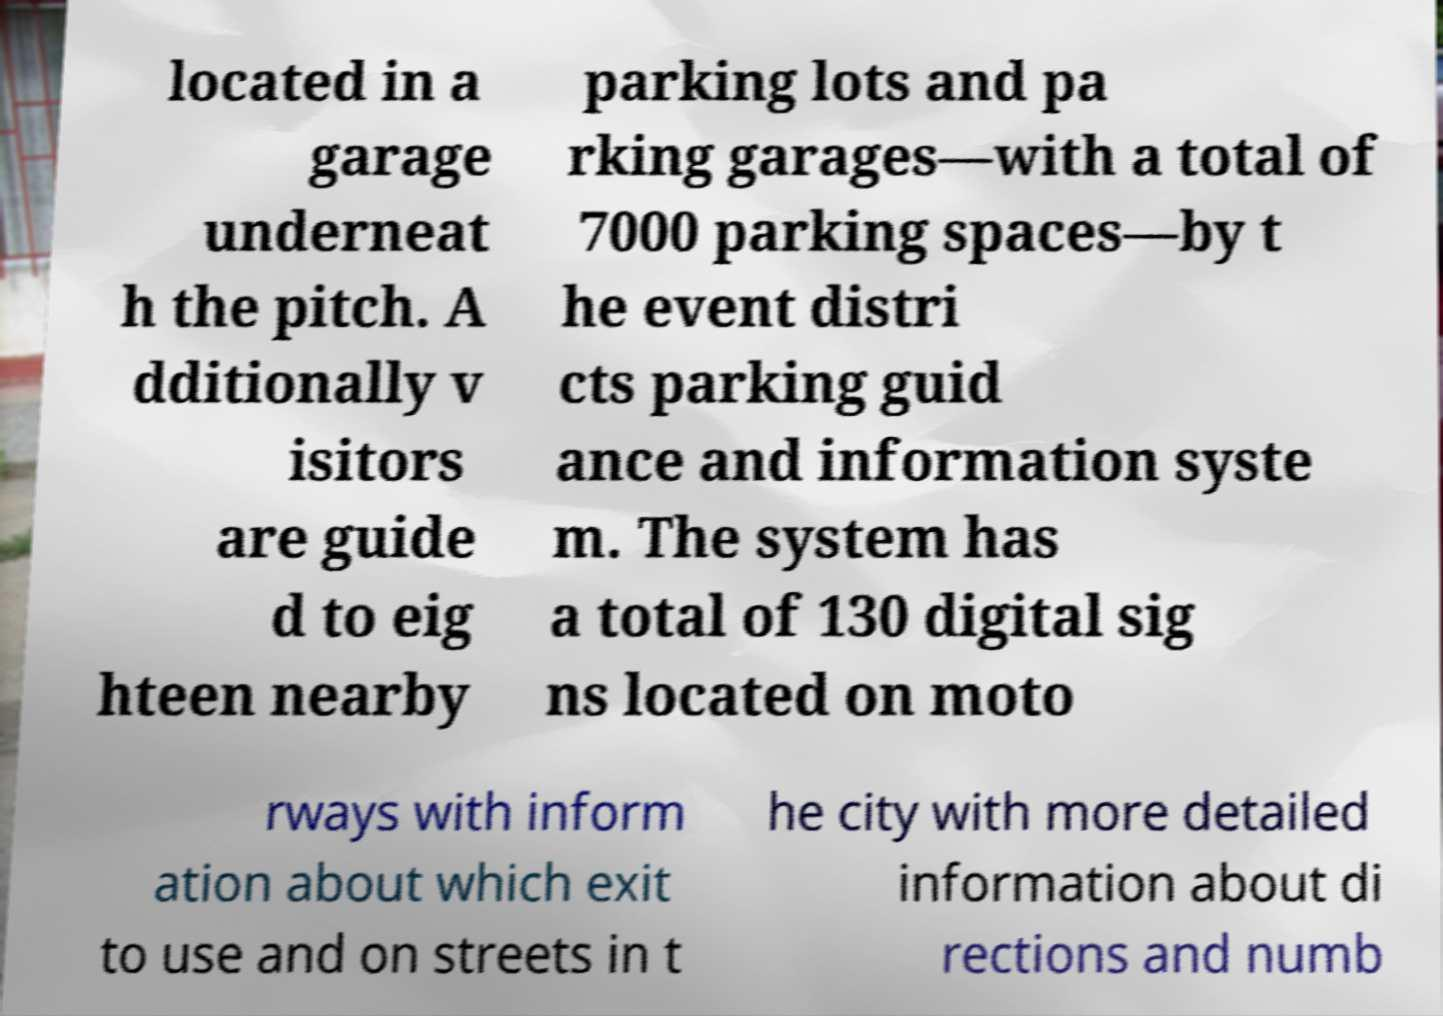Please identify and transcribe the text found in this image. The image displays a partially viewed informational text regarding event parking. It reads: 'located in a garage underneath the pitch. Additionally, visitors are guided to eighteen nearby parking lots and parking garages—with a total of 7000 parking spaces—by the event district's parking guidance and information system. The system has a total of 130 digital signs located on motorways with information about which exit to use and on streets in the city with more detailed information about directions and numbers.' 